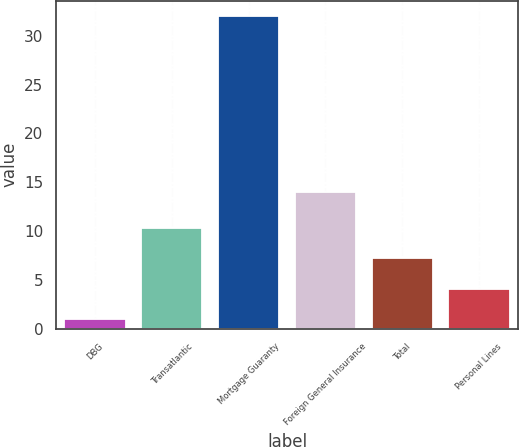Convert chart to OTSL. <chart><loc_0><loc_0><loc_500><loc_500><bar_chart><fcel>DBG<fcel>Transatlantic<fcel>Mortgage Guaranty<fcel>Foreign General Insurance<fcel>Total<fcel>Personal Lines<nl><fcel>1<fcel>10.3<fcel>32<fcel>14<fcel>7.2<fcel>4.1<nl></chart> 